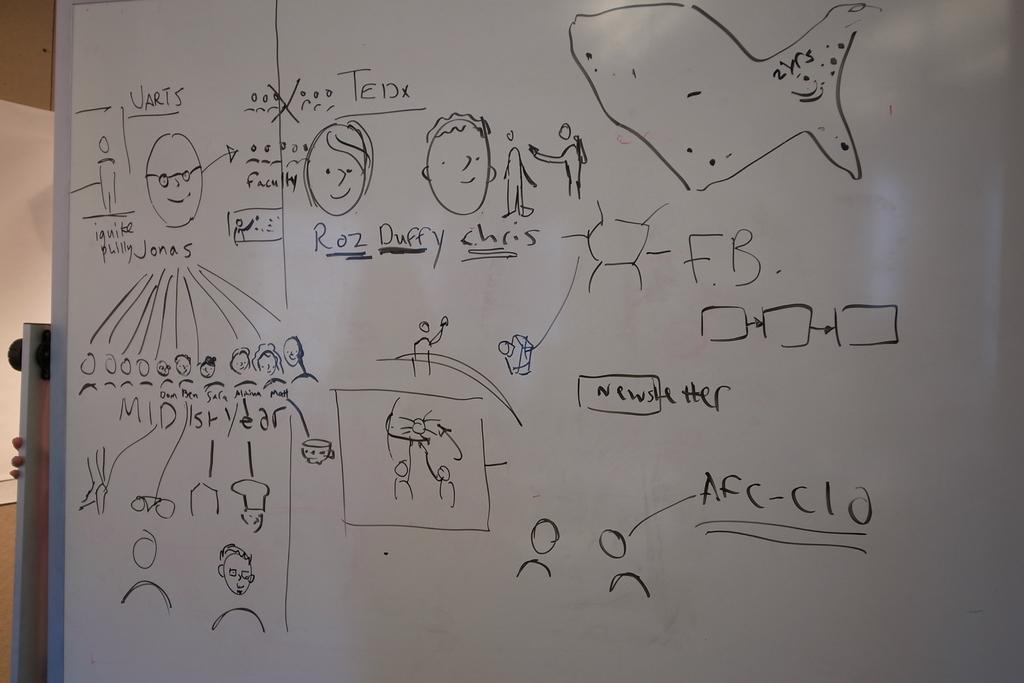<image>
Share a concise interpretation of the image provided. A whiteboard with faces and the name Ted written on it. 